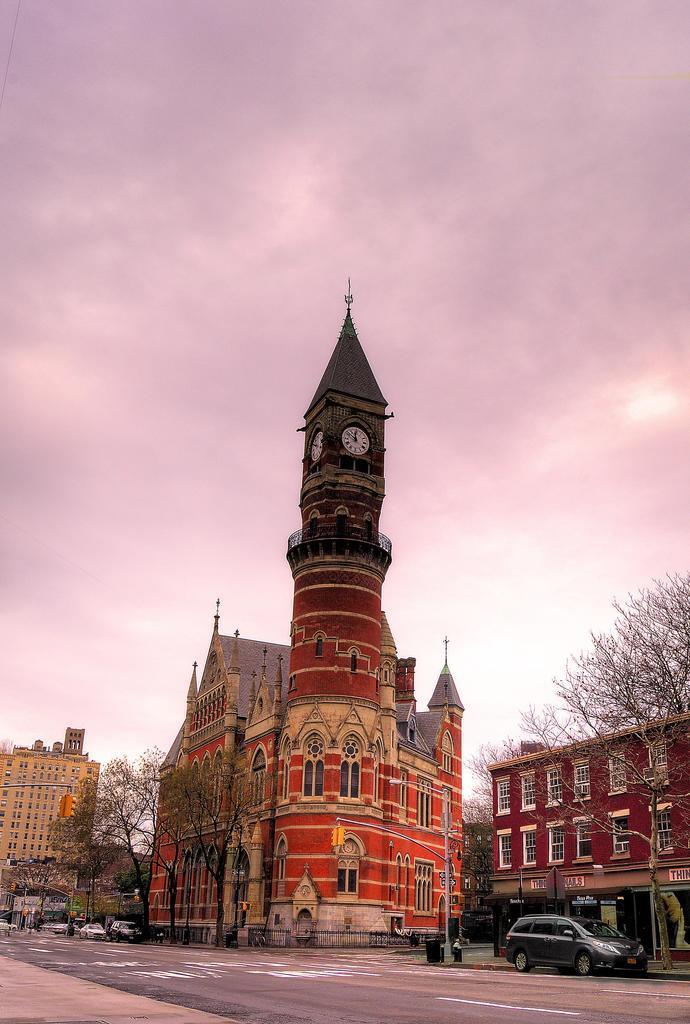Describe this image in one or two sentences. In this image there are buildings, in front of the buildings there are trees, beneath the trees there are few vehicles moving on the road. In the background there is a sky. 